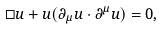Convert formula to latex. <formula><loc_0><loc_0><loc_500><loc_500>\square u + u ( \partial _ { \mu } u \cdot \partial ^ { \mu } u ) = 0 ,</formula> 